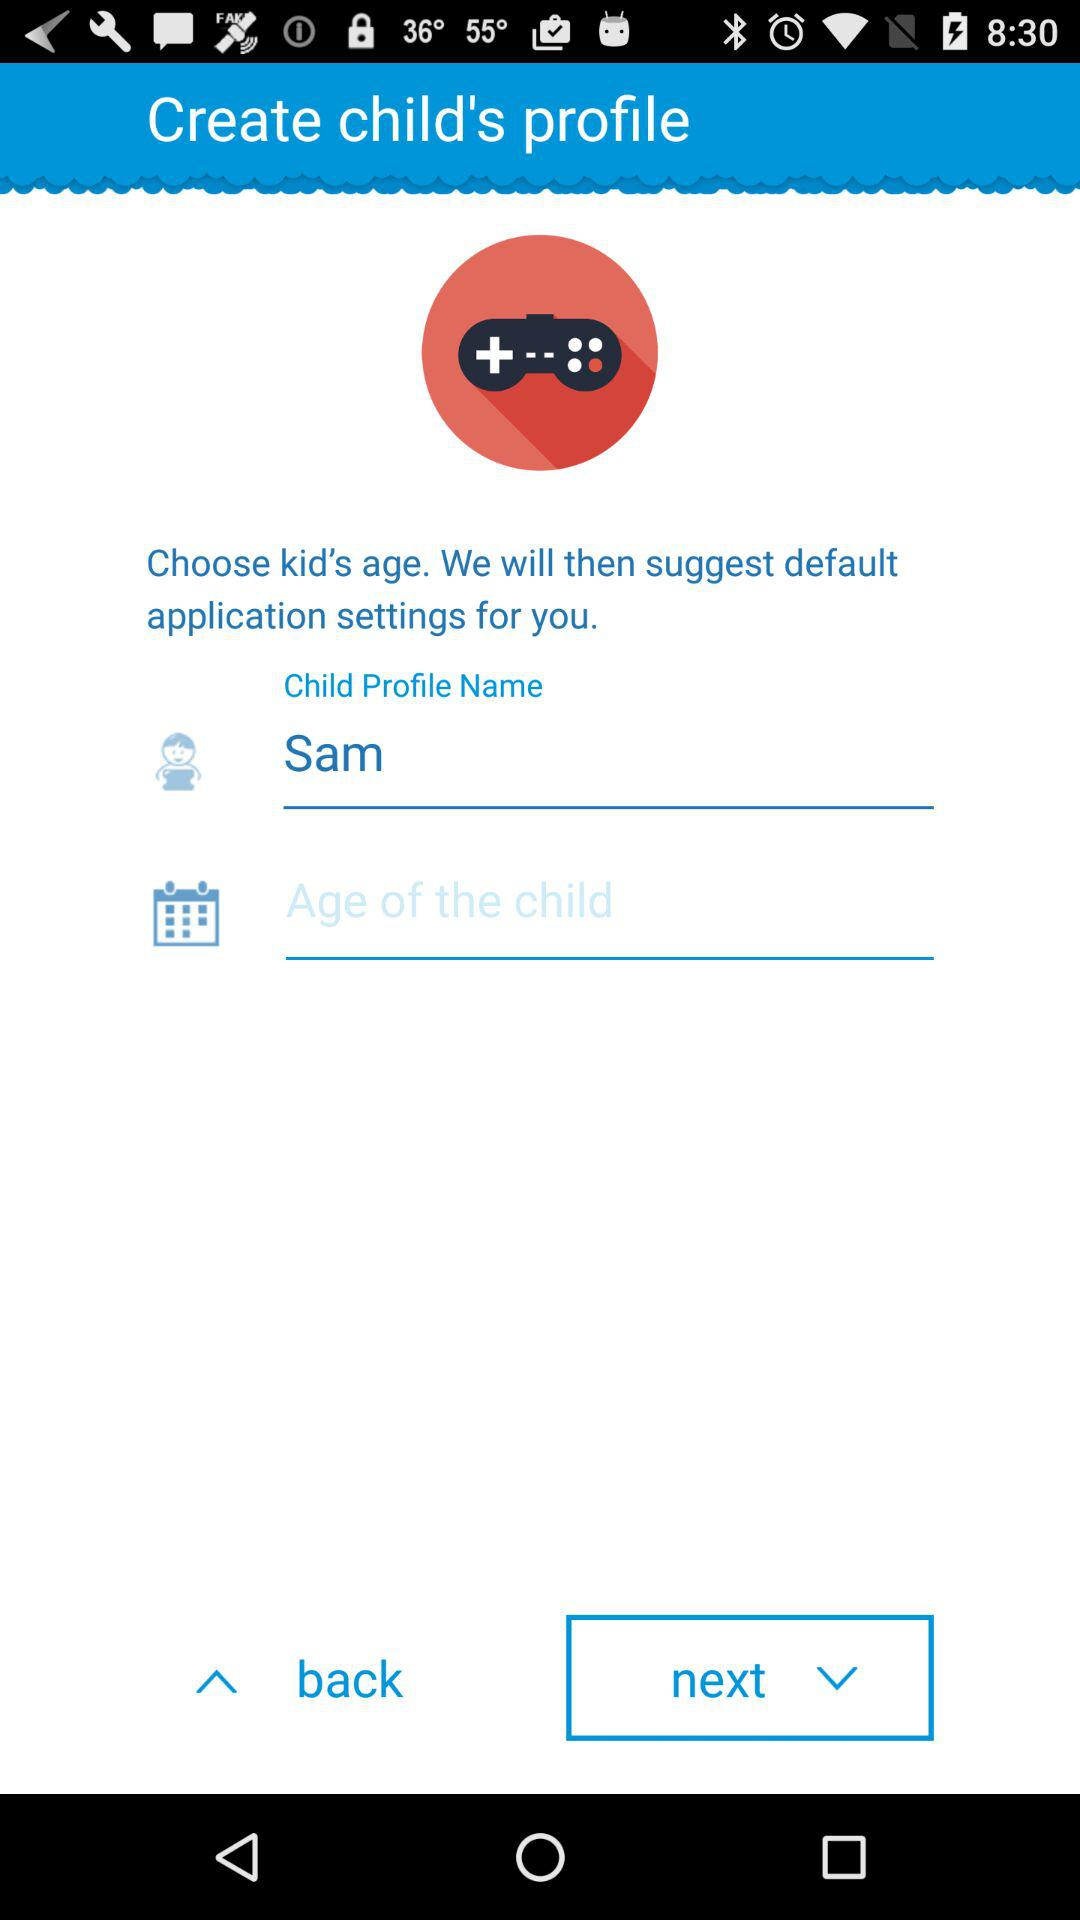What is the user name? The user name is Sam. 